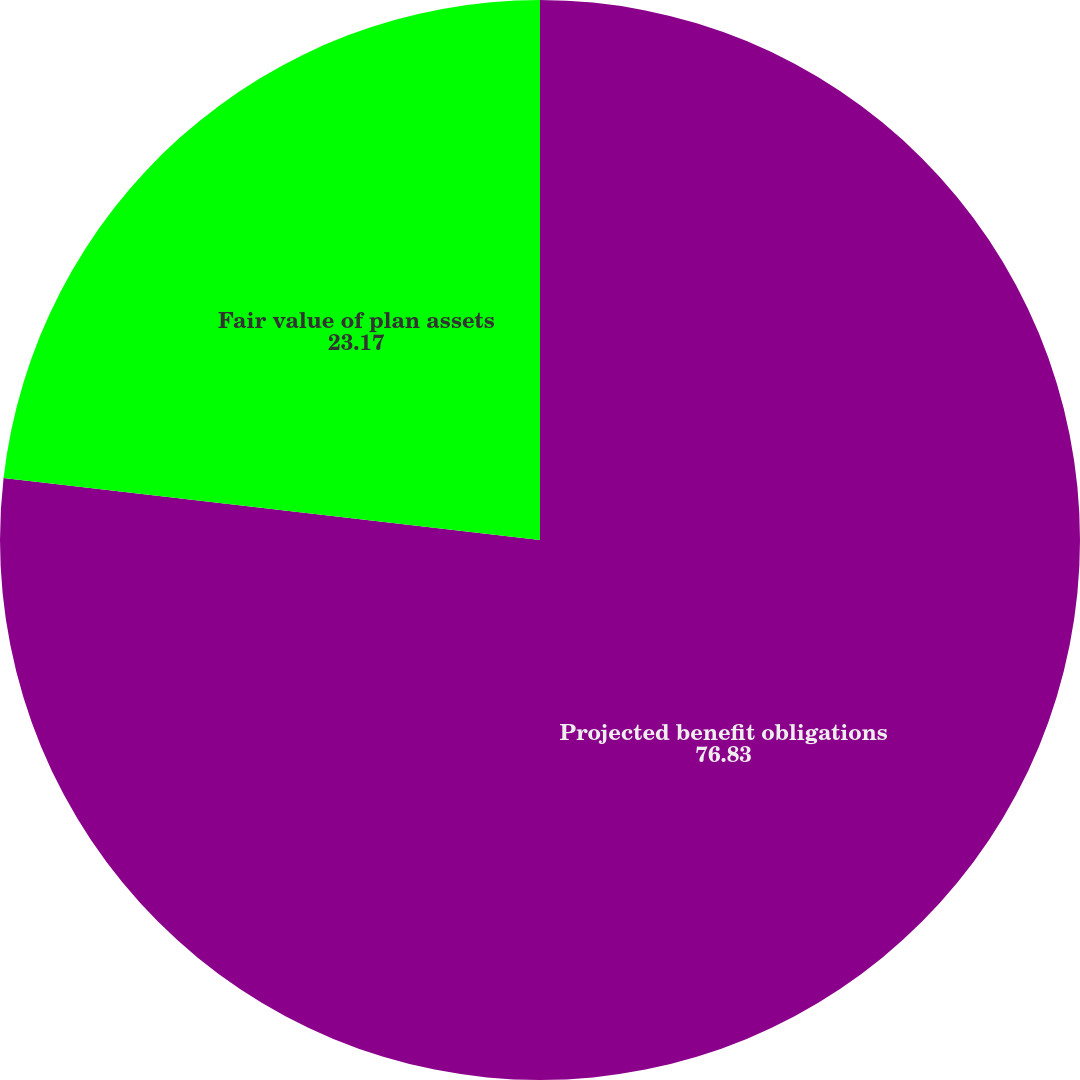<chart> <loc_0><loc_0><loc_500><loc_500><pie_chart><fcel>Projected benefit obligations<fcel>Fair value of plan assets<nl><fcel>76.83%<fcel>23.17%<nl></chart> 